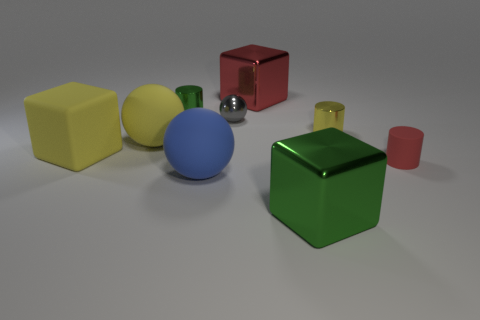Are there any patterns or designs on any of the objects? All the objects in the image have solid colors and lack any intricate patterns or designs. They present a minimalist aesthetic, which focuses on basic geometric shapes and uniform colors. 